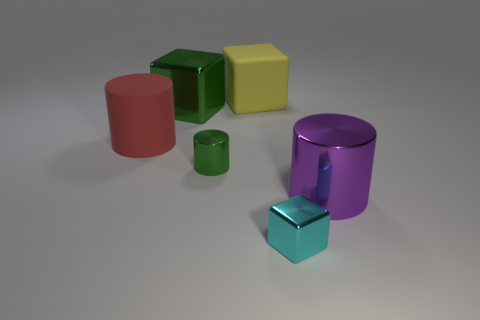Add 3 red objects. How many objects exist? 9 Subtract all large yellow matte blocks. Subtract all cyan metal blocks. How many objects are left? 4 Add 3 green shiny cylinders. How many green shiny cylinders are left? 4 Add 2 red cylinders. How many red cylinders exist? 3 Subtract 0 brown blocks. How many objects are left? 6 